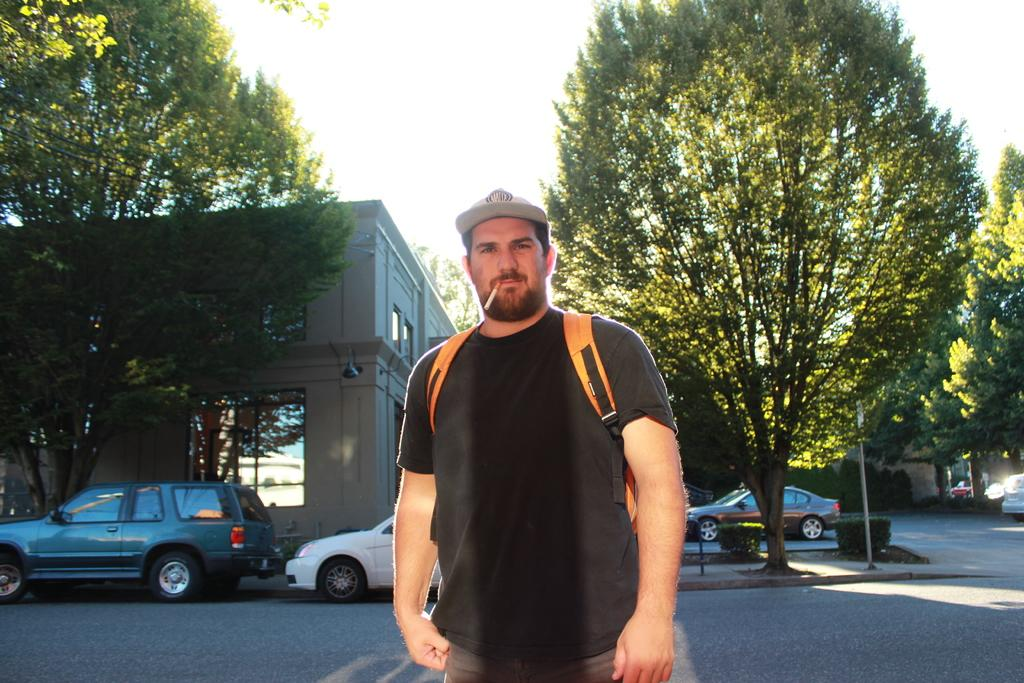What is the main subject of the image? There is a man in the image. What is the man wearing? The man is wearing a black t-shirt. Where is the man standing? The man is standing on a path. What can be seen in the background of the image? There are vehicles parked on the road, buildings, poles, and the sky visible in the background. How many lamps can be seen hanging from the poles in the image? There are no lamps visible in the image; only poles are present in the background. What type of wrench is the man holding in the image? The man is not holding a wrench in the image; he is wearing a black t-shirt and standing on a path. 